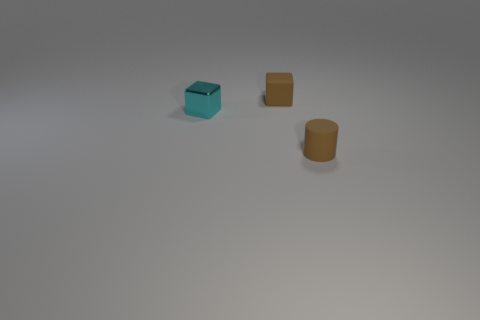How many things are metal things or small green metal spheres?
Provide a succinct answer. 1. There is a object that is to the right of the cyan object and in front of the brown block; what material is it?
Your answer should be very brief. Rubber. Does the brown rubber cylinder have the same size as the shiny cube?
Ensure brevity in your answer.  Yes. What size is the brown matte thing behind the cube that is to the left of the tiny matte cube?
Your answer should be very brief. Small. What number of tiny objects are on the right side of the cyan object and in front of the tiny brown rubber block?
Make the answer very short. 1. There is a tiny matte thing on the left side of the object in front of the cyan metallic cube; is there a brown thing that is left of it?
Your answer should be compact. No. There is a rubber thing that is the same size as the brown matte block; what shape is it?
Give a very brief answer. Cylinder. Are there any other cylinders of the same color as the tiny rubber cylinder?
Provide a succinct answer. No. How many large objects are cyan things or rubber objects?
Make the answer very short. 0. There is a object that is the same material as the small cylinder; what color is it?
Keep it short and to the point. Brown. 